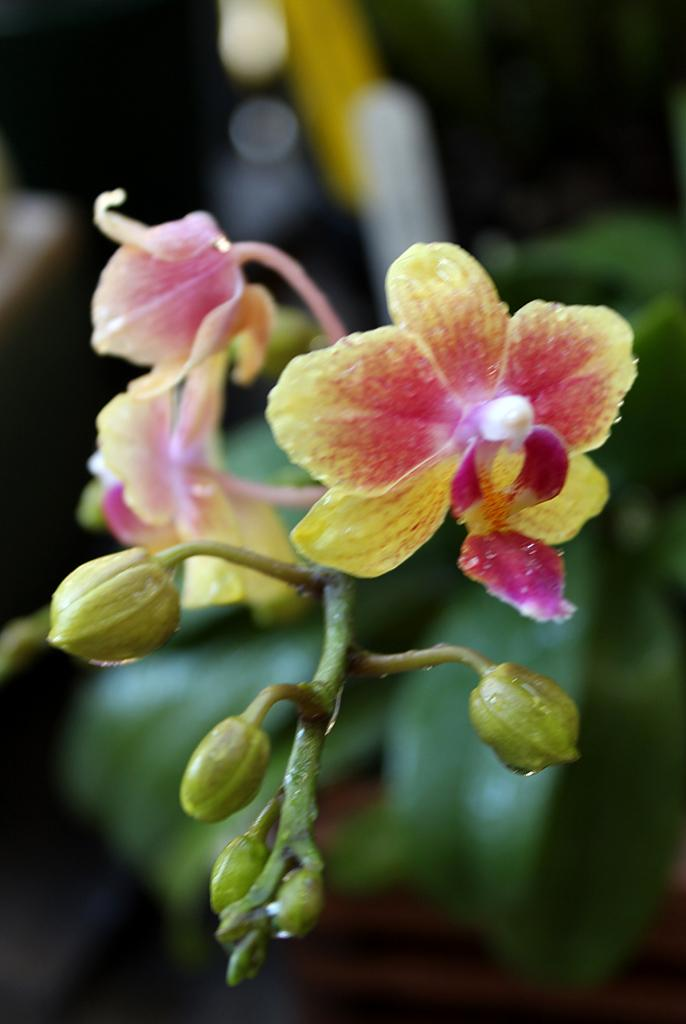What type of plants can be seen in the image? There are flowers in the image. Can you describe the stage of growth for some of the flowers? Yes, there are buds in the image. What colors are the flowers in the image? The flowers are in yellow and pink colors. How would you describe the background of the image? The background of the image is blurred. Where are the dolls placed in relation to the flowers in the image? There are no dolls present in the image. What type of trousers can be seen in the image? There are no trousers visible in the image. 